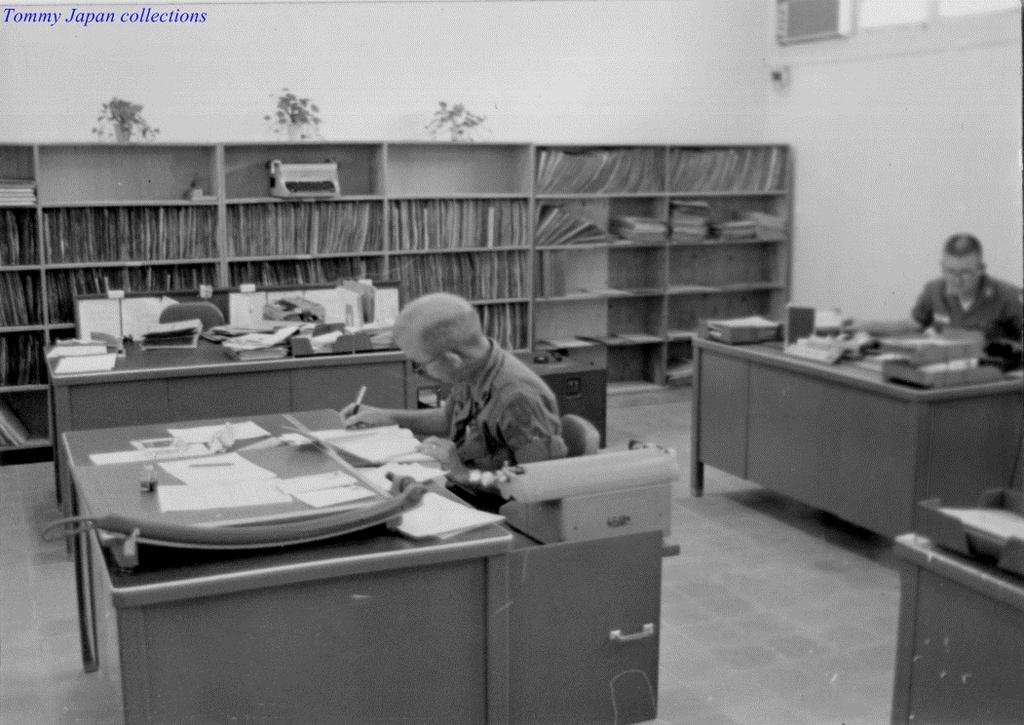How many people are sitting in the image? There are two people sitting on chairs in the image. What can be seen on the tables in the image? There are objects on the tables in the image. What type of items can be seen in the background of the image? There are books visible in a shelf in the background of the image. What type of disease is being discussed by the two people in the image? There is no indication in the image that the two people are discussing any disease. 